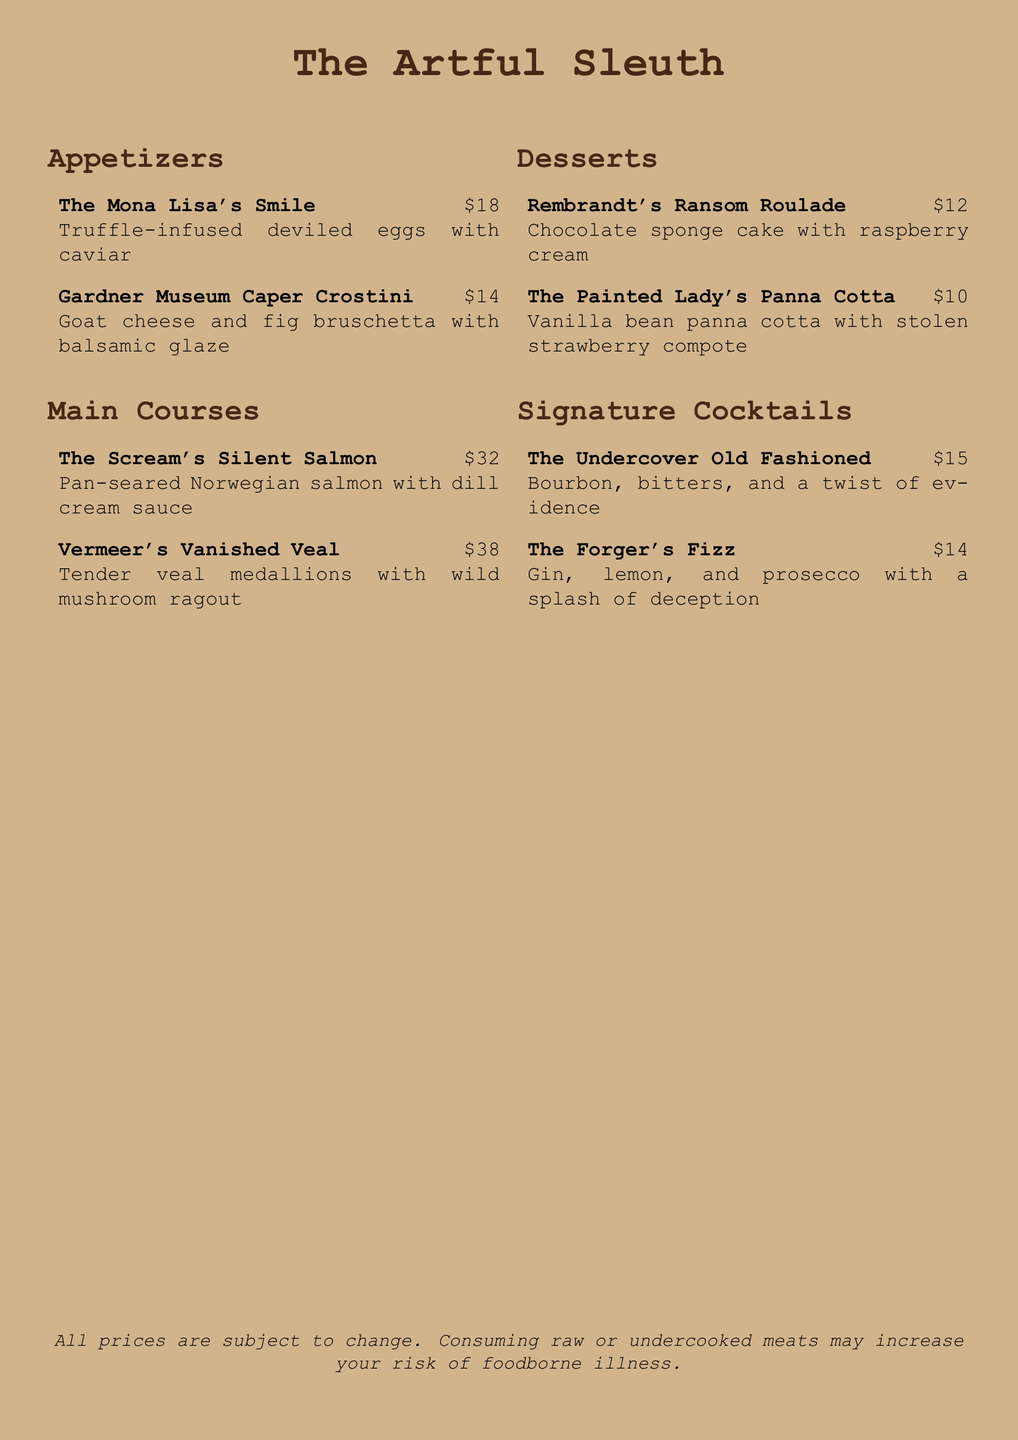What is the price of The Mona Lisa's Smile? The price of The Mona Lisa's Smile is directly listed on the menu.
Answer: $18 What type of fish is featured in The Scream's Silent Salmon? The name of the fish is specifically mentioned in the description of the dish.
Answer: Salmon How many main courses are listed on the menu? The number of main courses is counted from the list provided in the menu.
Answer: 2 What is the main ingredient in Rembrandt's Ransom Roulade? The key ingredient is highlighted in the name and description of the dessert.
Answer: Chocolate sponge cake What cocktail features gin as an ingredient? The ingredients of the cocktails are mentioned next to their names.
Answer: The Forger's Fizz Which appetizer includes goat cheese? The description of the appetizer lists goat cheese as one of the main components.
Answer: Gardner Museum Caper Crostini How much does The Painted Lady's Panna Cotta cost? The price is stated next to the dessert in the menu.
Answer: $10 What type of sauce accompanies the Norwegian salmon? The sauce is specifically mentioned in the description of the dish.
Answer: Dill cream sauce What is the total cost of ordering all the appetizers? The total cost can be calculated by summing the prices of both appetizers listed.
Answer: $32 